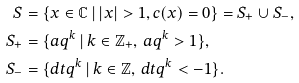<formula> <loc_0><loc_0><loc_500><loc_500>S & = \{ x \in { \mathbb { C } } \, | \, | x | > 1 , c ( x ) = 0 \} = S _ { + } \cup S _ { - } , \\ S _ { + } & = \{ a q ^ { k } \, | \, k \in { \mathbb { Z } } _ { + } , \, a q ^ { k } > 1 \} , \\ S _ { - } & = \{ d t q ^ { k } \, | \, k \in { \mathbb { Z } } , \, d t q ^ { k } < - 1 \} .</formula> 